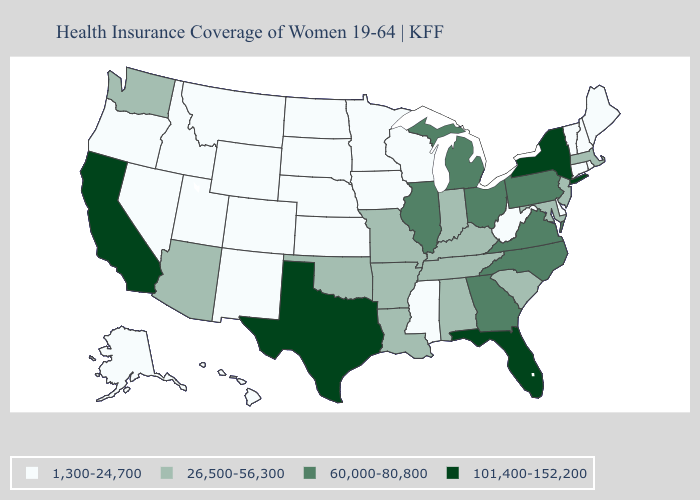Is the legend a continuous bar?
Quick response, please. No. Does Oklahoma have the same value as Virginia?
Short answer required. No. Name the states that have a value in the range 26,500-56,300?
Keep it brief. Alabama, Arizona, Arkansas, Indiana, Kentucky, Louisiana, Maryland, Massachusetts, Missouri, New Jersey, Oklahoma, South Carolina, Tennessee, Washington. What is the value of North Dakota?
Be succinct. 1,300-24,700. What is the value of Nebraska?
Quick response, please. 1,300-24,700. Is the legend a continuous bar?
Keep it brief. No. Does Michigan have the lowest value in the MidWest?
Write a very short answer. No. What is the value of Idaho?
Concise answer only. 1,300-24,700. Does Connecticut have the same value as Alaska?
Keep it brief. Yes. What is the value of New Jersey?
Concise answer only. 26,500-56,300. What is the value of New Mexico?
Answer briefly. 1,300-24,700. What is the lowest value in states that border Massachusetts?
Keep it brief. 1,300-24,700. Does Georgia have a lower value than Texas?
Be succinct. Yes. 